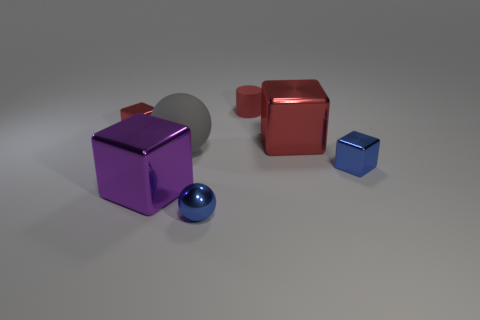Do the blue metal thing that is to the left of the small rubber thing and the small thing that is behind the small red cube have the same shape? No, they do not have the same shape. The blue metal object to the left of the rubber object is a cube, while the small object behind the small red cube is a sphere. Despite sharing a similar color and material finish, their geometric forms are distinct. 